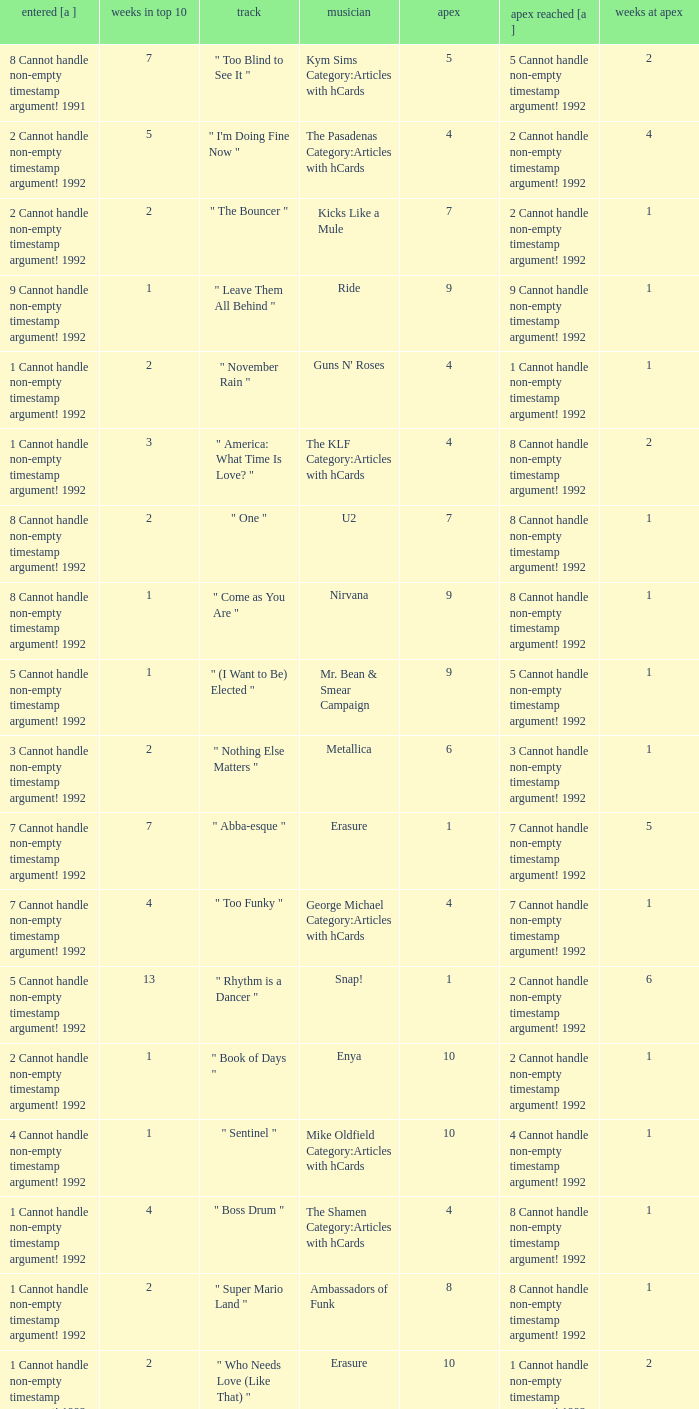If the peak is 9, how many weeks was it in the top 10? 1.0. 